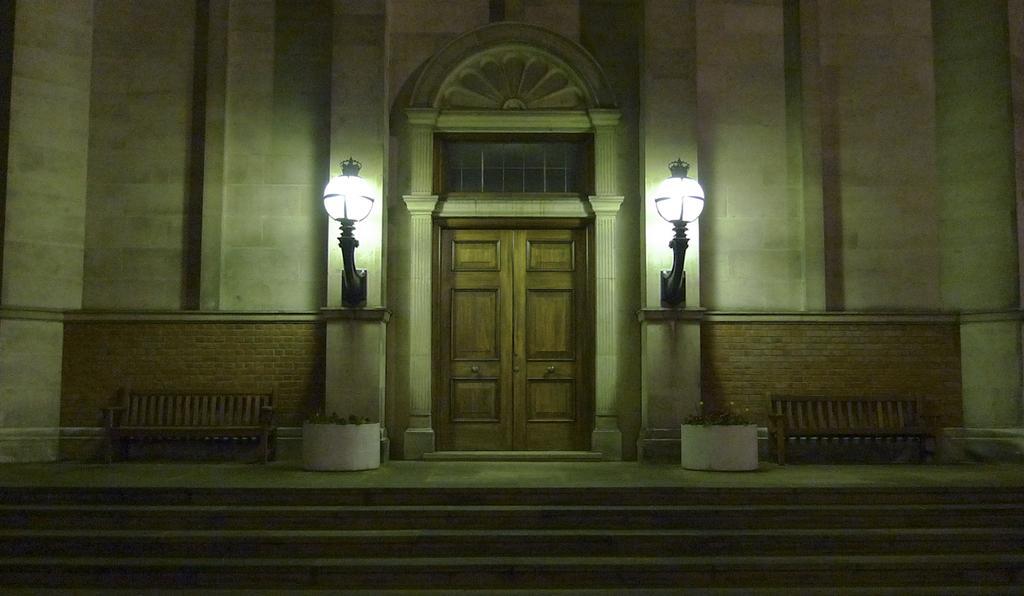How would you summarize this image in a sentence or two? In this picture I can see there is a door and there are two lamps on the wall , there is a building and there are some benches and there is a staircase here. 